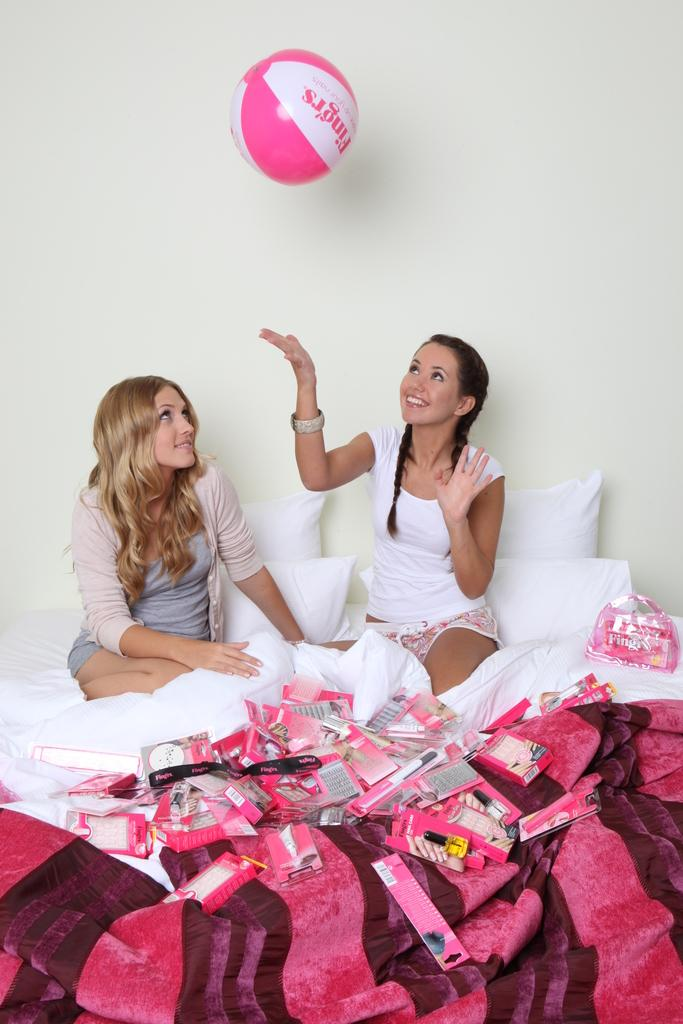How many girls are in the image? There are two girls in the image. What are the girls doing in the image? The girls are sitting on a bed and playing with a pink ball. What color is the bed sheet on the bed? The bed sheet is pink. What color are the pillows on the bed? The pillows are white. What is the background behind the girls? There is a wall behind the girls. What type of chalk is the girls using to draw on the wall in the image? There is no chalk present in the image, and the girls are not drawing on the wall. 